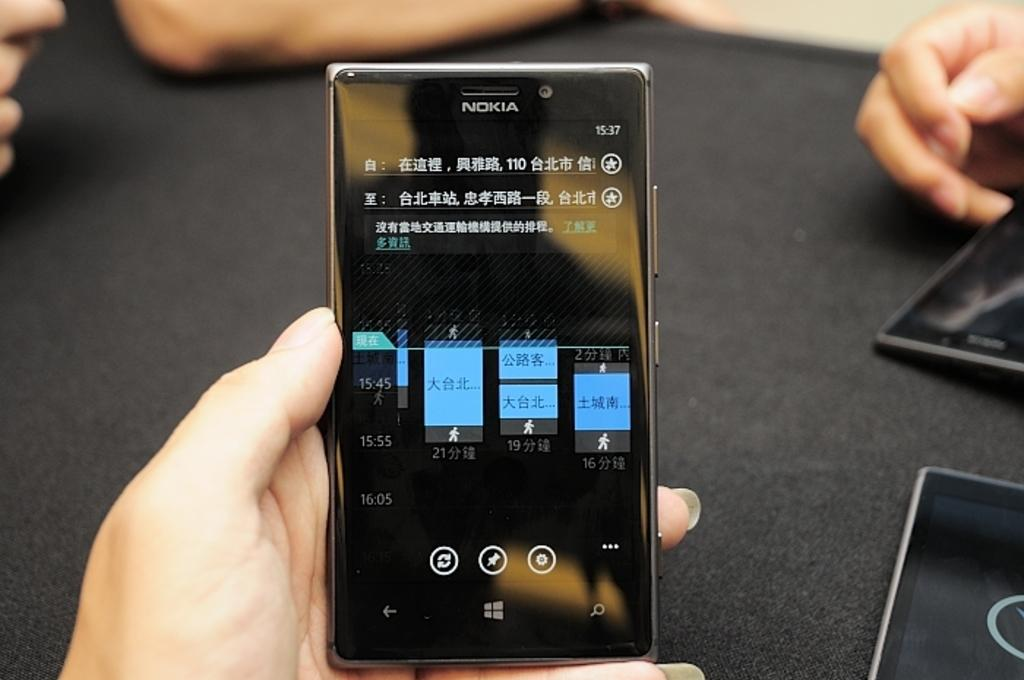<image>
Provide a brief description of the given image. A person is holding a phone that says Nokia. 